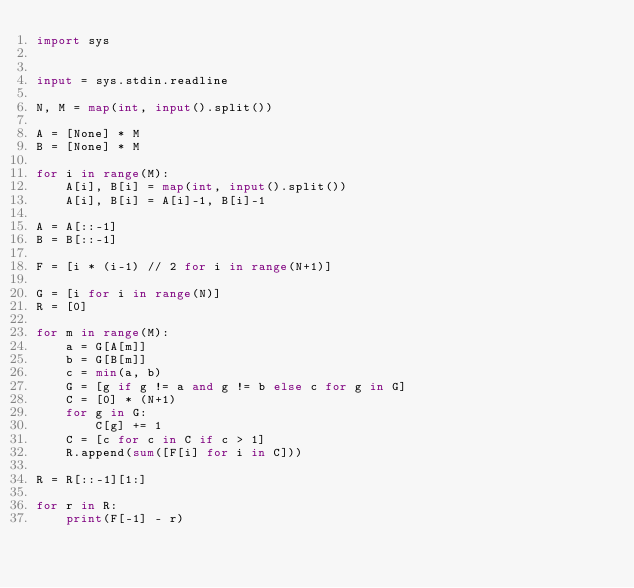Convert code to text. <code><loc_0><loc_0><loc_500><loc_500><_Python_>import sys


input = sys.stdin.readline

N, M = map(int, input().split())

A = [None] * M
B = [None] * M

for i in range(M):
    A[i], B[i] = map(int, input().split())
    A[i], B[i] = A[i]-1, B[i]-1

A = A[::-1]
B = B[::-1]

F = [i * (i-1) // 2 for i in range(N+1)]

G = [i for i in range(N)]
R = [0]

for m in range(M):
    a = G[A[m]]
    b = G[B[m]]
    c = min(a, b)
    G = [g if g != a and g != b else c for g in G]
    C = [0] * (N+1)
    for g in G:
        C[g] += 1
    C = [c for c in C if c > 1]
    R.append(sum([F[i] for i in C]))

R = R[::-1][1:]

for r in R:
    print(F[-1] - r)
</code> 